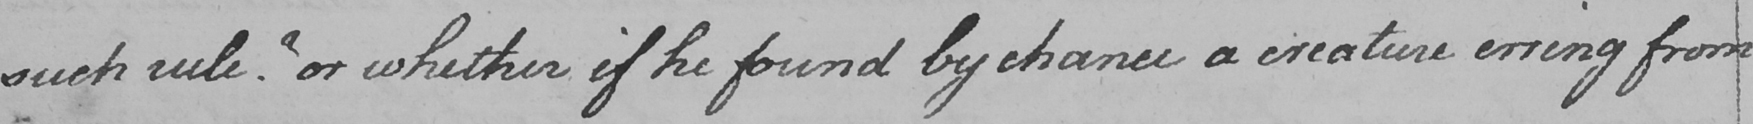What does this handwritten line say? such rule ?  or whether if he found by chance a creature erring from 